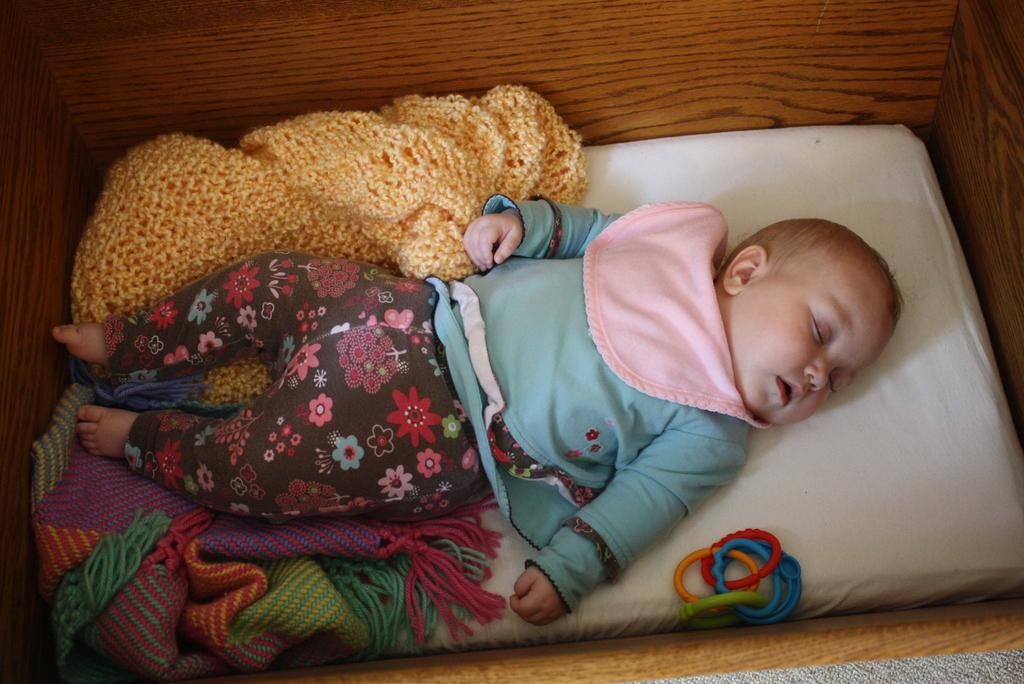What is the main subject of the image? There is a baby in the center of the image. Where is the baby located? The baby is sleeping on a bed. What is underneath the baby on the bed? There are blankets under the baby. What can be seen at the bottom of the bed? There is a toy at the bottom of the bed. How many parcels are being delivered to the baby in the image? There are no parcels present in the image; it features a baby sleeping on a bed with blankets and a toy. 